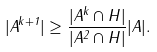<formula> <loc_0><loc_0><loc_500><loc_500>| A ^ { k + 1 } | \geq \frac { | A ^ { k } \cap H | } { | A ^ { 2 } \cap H | } | A | .</formula> 